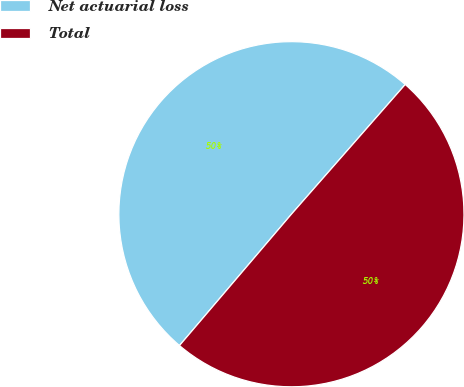Convert chart to OTSL. <chart><loc_0><loc_0><loc_500><loc_500><pie_chart><fcel>Net actuarial loss<fcel>Total<nl><fcel>50.23%<fcel>49.77%<nl></chart> 